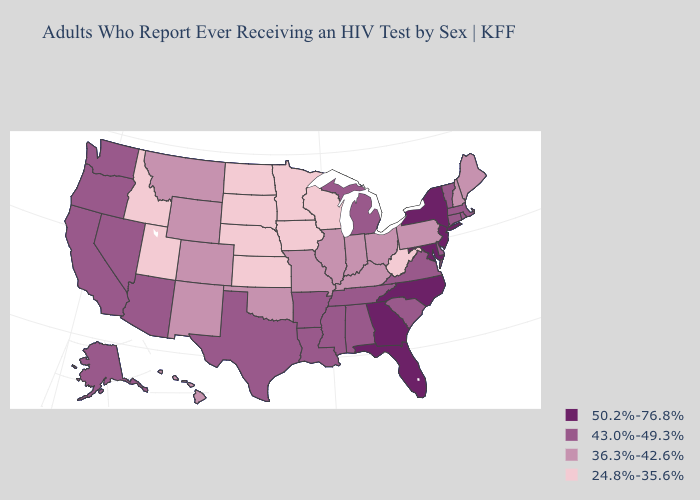Does Wyoming have a higher value than Iowa?
Be succinct. Yes. What is the lowest value in states that border Georgia?
Be succinct. 43.0%-49.3%. Name the states that have a value in the range 43.0%-49.3%?
Be succinct. Alabama, Alaska, Arizona, Arkansas, California, Connecticut, Delaware, Louisiana, Massachusetts, Michigan, Mississippi, Nevada, Oregon, Rhode Island, South Carolina, Tennessee, Texas, Vermont, Virginia, Washington. What is the lowest value in states that border Rhode Island?
Short answer required. 43.0%-49.3%. Does the map have missing data?
Be succinct. No. What is the value of Mississippi?
Short answer required. 43.0%-49.3%. Which states have the lowest value in the USA?
Give a very brief answer. Idaho, Iowa, Kansas, Minnesota, Nebraska, North Dakota, South Dakota, Utah, West Virginia, Wisconsin. What is the value of Massachusetts?
Write a very short answer. 43.0%-49.3%. Name the states that have a value in the range 36.3%-42.6%?
Quick response, please. Colorado, Hawaii, Illinois, Indiana, Kentucky, Maine, Missouri, Montana, New Hampshire, New Mexico, Ohio, Oklahoma, Pennsylvania, Wyoming. What is the value of Connecticut?
Answer briefly. 43.0%-49.3%. Name the states that have a value in the range 24.8%-35.6%?
Quick response, please. Idaho, Iowa, Kansas, Minnesota, Nebraska, North Dakota, South Dakota, Utah, West Virginia, Wisconsin. What is the value of Indiana?
Concise answer only. 36.3%-42.6%. Among the states that border New Hampshire , which have the lowest value?
Keep it brief. Maine. Does West Virginia have a higher value than Illinois?
Give a very brief answer. No. 